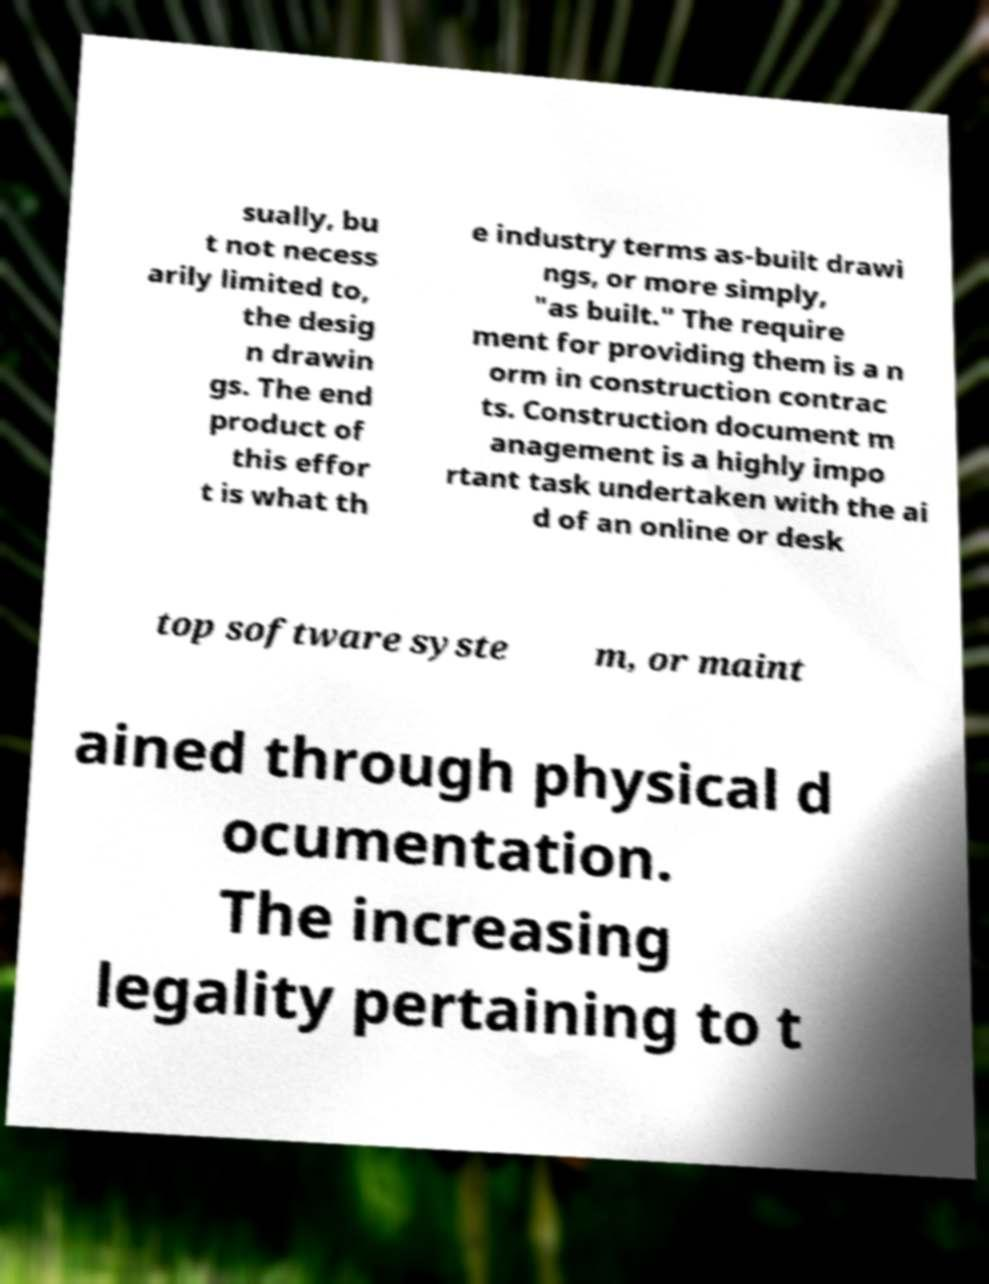Can you read and provide the text displayed in the image?This photo seems to have some interesting text. Can you extract and type it out for me? sually, bu t not necess arily limited to, the desig n drawin gs. The end product of this effor t is what th e industry terms as-built drawi ngs, or more simply, "as built." The require ment for providing them is a n orm in construction contrac ts. Construction document m anagement is a highly impo rtant task undertaken with the ai d of an online or desk top software syste m, or maint ained through physical d ocumentation. The increasing legality pertaining to t 